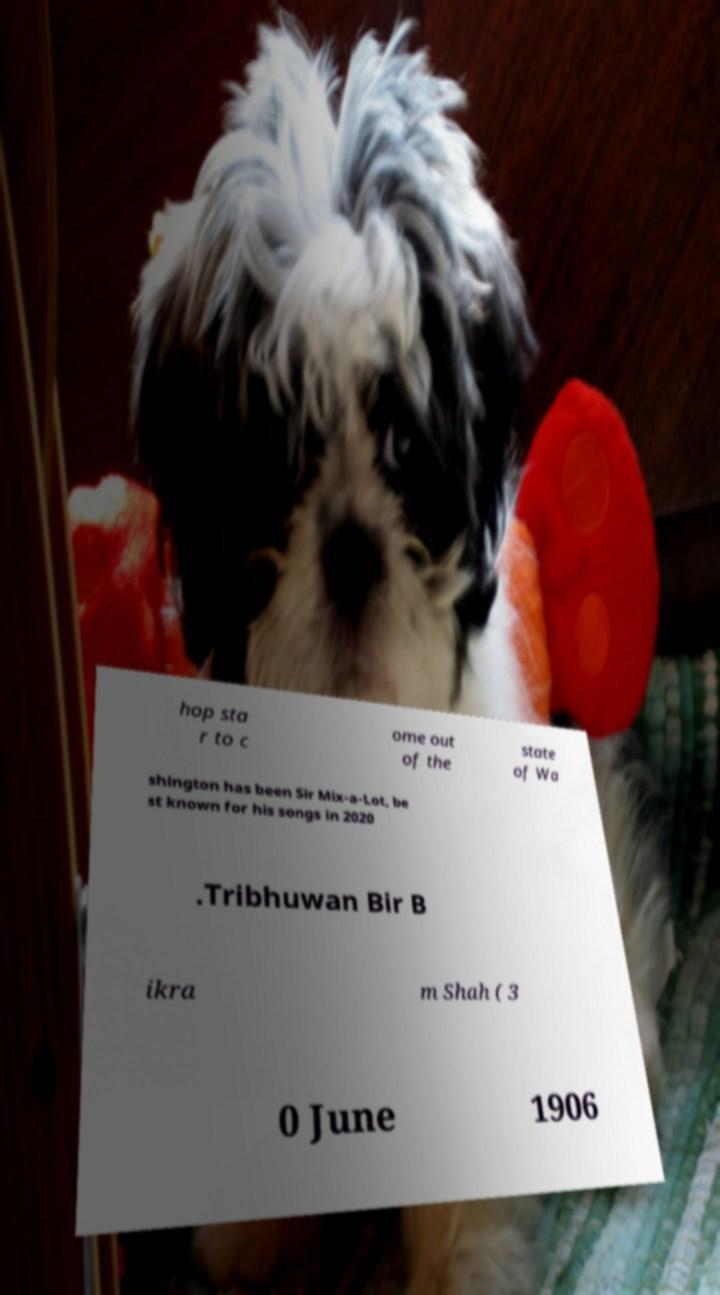Can you accurately transcribe the text from the provided image for me? hop sta r to c ome out of the state of Wa shington has been Sir Mix-a-Lot, be st known for his songs in 2020 .Tribhuwan Bir B ikra m Shah ( 3 0 June 1906 